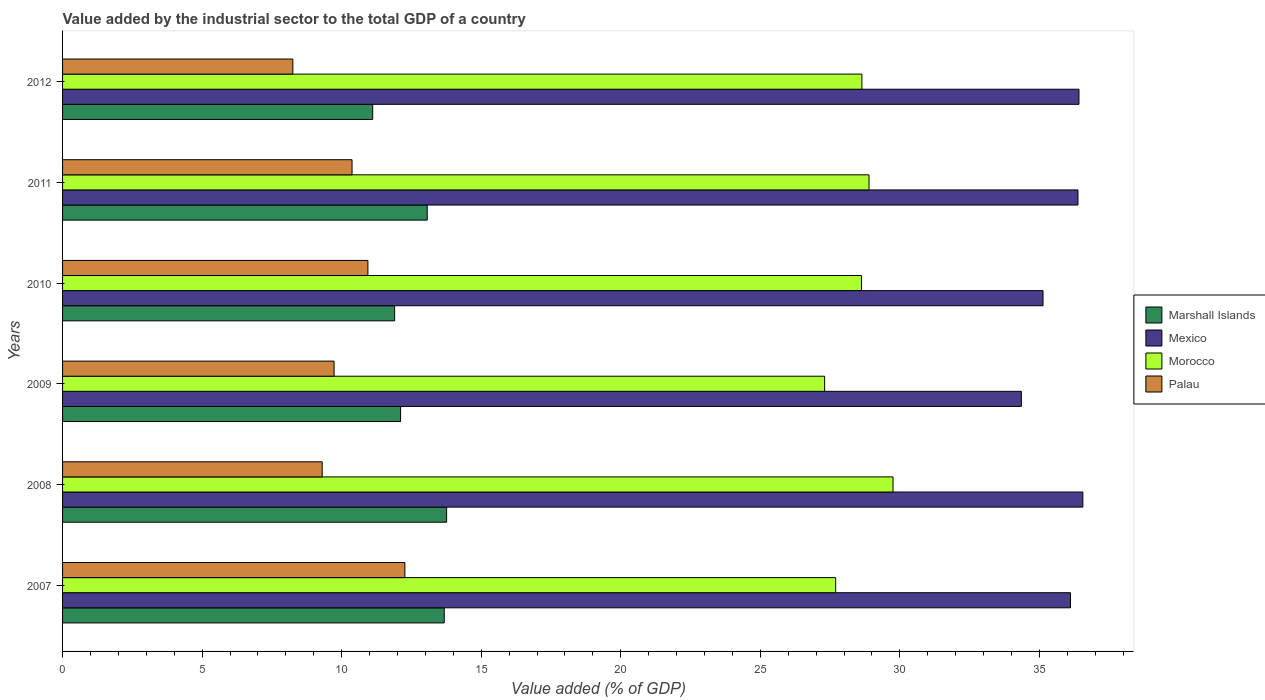Are the number of bars per tick equal to the number of legend labels?
Make the answer very short. Yes. Are the number of bars on each tick of the Y-axis equal?
Offer a terse response. Yes. How many bars are there on the 4th tick from the top?
Ensure brevity in your answer.  4. In how many cases, is the number of bars for a given year not equal to the number of legend labels?
Your response must be concise. 0. What is the value added by the industrial sector to the total GDP in Marshall Islands in 2007?
Your answer should be very brief. 13.68. Across all years, what is the maximum value added by the industrial sector to the total GDP in Marshall Islands?
Offer a terse response. 13.76. Across all years, what is the minimum value added by the industrial sector to the total GDP in Palau?
Keep it short and to the point. 8.25. What is the total value added by the industrial sector to the total GDP in Morocco in the graph?
Your answer should be very brief. 170.91. What is the difference between the value added by the industrial sector to the total GDP in Mexico in 2007 and that in 2008?
Make the answer very short. -0.44. What is the difference between the value added by the industrial sector to the total GDP in Marshall Islands in 2008 and the value added by the industrial sector to the total GDP in Palau in 2007?
Offer a terse response. 1.5. What is the average value added by the industrial sector to the total GDP in Palau per year?
Give a very brief answer. 10.14. In the year 2010, what is the difference between the value added by the industrial sector to the total GDP in Marshall Islands and value added by the industrial sector to the total GDP in Mexico?
Provide a short and direct response. -23.23. What is the ratio of the value added by the industrial sector to the total GDP in Palau in 2008 to that in 2012?
Give a very brief answer. 1.13. Is the difference between the value added by the industrial sector to the total GDP in Marshall Islands in 2009 and 2012 greater than the difference between the value added by the industrial sector to the total GDP in Mexico in 2009 and 2012?
Provide a succinct answer. Yes. What is the difference between the highest and the second highest value added by the industrial sector to the total GDP in Mexico?
Give a very brief answer. 0.14. What is the difference between the highest and the lowest value added by the industrial sector to the total GDP in Palau?
Keep it short and to the point. 4.01. Is it the case that in every year, the sum of the value added by the industrial sector to the total GDP in Mexico and value added by the industrial sector to the total GDP in Morocco is greater than the sum of value added by the industrial sector to the total GDP in Palau and value added by the industrial sector to the total GDP in Marshall Islands?
Your answer should be very brief. No. What does the 1st bar from the top in 2008 represents?
Your answer should be compact. Palau. What does the 3rd bar from the bottom in 2009 represents?
Make the answer very short. Morocco. Is it the case that in every year, the sum of the value added by the industrial sector to the total GDP in Mexico and value added by the industrial sector to the total GDP in Marshall Islands is greater than the value added by the industrial sector to the total GDP in Palau?
Provide a short and direct response. Yes. How many bars are there?
Your answer should be compact. 24. Are all the bars in the graph horizontal?
Your answer should be very brief. Yes. How many years are there in the graph?
Ensure brevity in your answer.  6. What is the difference between two consecutive major ticks on the X-axis?
Your answer should be compact. 5. Are the values on the major ticks of X-axis written in scientific E-notation?
Make the answer very short. No. Does the graph contain grids?
Offer a terse response. No. How many legend labels are there?
Make the answer very short. 4. How are the legend labels stacked?
Provide a succinct answer. Vertical. What is the title of the graph?
Your answer should be compact. Value added by the industrial sector to the total GDP of a country. What is the label or title of the X-axis?
Make the answer very short. Value added (% of GDP). What is the Value added (% of GDP) in Marshall Islands in 2007?
Your answer should be very brief. 13.68. What is the Value added (% of GDP) in Mexico in 2007?
Provide a succinct answer. 36.11. What is the Value added (% of GDP) in Morocco in 2007?
Your answer should be very brief. 27.7. What is the Value added (% of GDP) of Palau in 2007?
Offer a terse response. 12.26. What is the Value added (% of GDP) in Marshall Islands in 2008?
Ensure brevity in your answer.  13.76. What is the Value added (% of GDP) of Mexico in 2008?
Give a very brief answer. 36.56. What is the Value added (% of GDP) in Morocco in 2008?
Keep it short and to the point. 29.75. What is the Value added (% of GDP) in Palau in 2008?
Keep it short and to the point. 9.3. What is the Value added (% of GDP) in Marshall Islands in 2009?
Offer a very short reply. 12.11. What is the Value added (% of GDP) in Mexico in 2009?
Keep it short and to the point. 34.35. What is the Value added (% of GDP) in Morocco in 2009?
Offer a terse response. 27.3. What is the Value added (% of GDP) in Palau in 2009?
Offer a very short reply. 9.73. What is the Value added (% of GDP) in Marshall Islands in 2010?
Make the answer very short. 11.9. What is the Value added (% of GDP) in Mexico in 2010?
Offer a terse response. 35.13. What is the Value added (% of GDP) of Morocco in 2010?
Your answer should be very brief. 28.62. What is the Value added (% of GDP) in Palau in 2010?
Give a very brief answer. 10.94. What is the Value added (% of GDP) in Marshall Islands in 2011?
Make the answer very short. 13.07. What is the Value added (% of GDP) of Mexico in 2011?
Your response must be concise. 36.38. What is the Value added (% of GDP) of Morocco in 2011?
Give a very brief answer. 28.89. What is the Value added (% of GDP) of Palau in 2011?
Keep it short and to the point. 10.37. What is the Value added (% of GDP) in Marshall Islands in 2012?
Your response must be concise. 11.11. What is the Value added (% of GDP) of Mexico in 2012?
Offer a terse response. 36.42. What is the Value added (% of GDP) of Morocco in 2012?
Provide a succinct answer. 28.64. What is the Value added (% of GDP) in Palau in 2012?
Make the answer very short. 8.25. Across all years, what is the maximum Value added (% of GDP) of Marshall Islands?
Give a very brief answer. 13.76. Across all years, what is the maximum Value added (% of GDP) in Mexico?
Your answer should be compact. 36.56. Across all years, what is the maximum Value added (% of GDP) of Morocco?
Keep it short and to the point. 29.75. Across all years, what is the maximum Value added (% of GDP) in Palau?
Your answer should be very brief. 12.26. Across all years, what is the minimum Value added (% of GDP) of Marshall Islands?
Your answer should be compact. 11.11. Across all years, what is the minimum Value added (% of GDP) of Mexico?
Your answer should be compact. 34.35. Across all years, what is the minimum Value added (% of GDP) of Morocco?
Your answer should be compact. 27.3. Across all years, what is the minimum Value added (% of GDP) in Palau?
Your response must be concise. 8.25. What is the total Value added (% of GDP) in Marshall Islands in the graph?
Provide a succinct answer. 75.62. What is the total Value added (% of GDP) in Mexico in the graph?
Ensure brevity in your answer.  214.95. What is the total Value added (% of GDP) in Morocco in the graph?
Make the answer very short. 170.91. What is the total Value added (% of GDP) in Palau in the graph?
Make the answer very short. 60.86. What is the difference between the Value added (% of GDP) in Marshall Islands in 2007 and that in 2008?
Provide a short and direct response. -0.08. What is the difference between the Value added (% of GDP) in Mexico in 2007 and that in 2008?
Provide a succinct answer. -0.44. What is the difference between the Value added (% of GDP) in Morocco in 2007 and that in 2008?
Make the answer very short. -2.06. What is the difference between the Value added (% of GDP) in Palau in 2007 and that in 2008?
Offer a terse response. 2.96. What is the difference between the Value added (% of GDP) of Marshall Islands in 2007 and that in 2009?
Ensure brevity in your answer.  1.56. What is the difference between the Value added (% of GDP) in Mexico in 2007 and that in 2009?
Your answer should be very brief. 1.76. What is the difference between the Value added (% of GDP) in Morocco in 2007 and that in 2009?
Keep it short and to the point. 0.4. What is the difference between the Value added (% of GDP) of Palau in 2007 and that in 2009?
Offer a very short reply. 2.54. What is the difference between the Value added (% of GDP) in Marshall Islands in 2007 and that in 2010?
Provide a succinct answer. 1.78. What is the difference between the Value added (% of GDP) of Mexico in 2007 and that in 2010?
Provide a succinct answer. 0.98. What is the difference between the Value added (% of GDP) of Morocco in 2007 and that in 2010?
Give a very brief answer. -0.92. What is the difference between the Value added (% of GDP) in Palau in 2007 and that in 2010?
Your answer should be compact. 1.32. What is the difference between the Value added (% of GDP) in Marshall Islands in 2007 and that in 2011?
Provide a succinct answer. 0.61. What is the difference between the Value added (% of GDP) in Mexico in 2007 and that in 2011?
Your answer should be compact. -0.27. What is the difference between the Value added (% of GDP) in Morocco in 2007 and that in 2011?
Provide a succinct answer. -1.19. What is the difference between the Value added (% of GDP) in Palau in 2007 and that in 2011?
Your answer should be very brief. 1.89. What is the difference between the Value added (% of GDP) of Marshall Islands in 2007 and that in 2012?
Provide a succinct answer. 2.56. What is the difference between the Value added (% of GDP) of Mexico in 2007 and that in 2012?
Keep it short and to the point. -0.3. What is the difference between the Value added (% of GDP) in Morocco in 2007 and that in 2012?
Offer a terse response. -0.94. What is the difference between the Value added (% of GDP) in Palau in 2007 and that in 2012?
Offer a very short reply. 4.01. What is the difference between the Value added (% of GDP) of Marshall Islands in 2008 and that in 2009?
Your answer should be compact. 1.65. What is the difference between the Value added (% of GDP) of Mexico in 2008 and that in 2009?
Offer a very short reply. 2.2. What is the difference between the Value added (% of GDP) in Morocco in 2008 and that in 2009?
Offer a very short reply. 2.45. What is the difference between the Value added (% of GDP) of Palau in 2008 and that in 2009?
Give a very brief answer. -0.43. What is the difference between the Value added (% of GDP) of Marshall Islands in 2008 and that in 2010?
Make the answer very short. 1.86. What is the difference between the Value added (% of GDP) in Mexico in 2008 and that in 2010?
Your answer should be compact. 1.43. What is the difference between the Value added (% of GDP) in Morocco in 2008 and that in 2010?
Give a very brief answer. 1.13. What is the difference between the Value added (% of GDP) in Palau in 2008 and that in 2010?
Make the answer very short. -1.64. What is the difference between the Value added (% of GDP) in Marshall Islands in 2008 and that in 2011?
Provide a short and direct response. 0.69. What is the difference between the Value added (% of GDP) of Mexico in 2008 and that in 2011?
Give a very brief answer. 0.17. What is the difference between the Value added (% of GDP) of Morocco in 2008 and that in 2011?
Keep it short and to the point. 0.86. What is the difference between the Value added (% of GDP) of Palau in 2008 and that in 2011?
Ensure brevity in your answer.  -1.07. What is the difference between the Value added (% of GDP) of Marshall Islands in 2008 and that in 2012?
Your answer should be very brief. 2.65. What is the difference between the Value added (% of GDP) in Mexico in 2008 and that in 2012?
Give a very brief answer. 0.14. What is the difference between the Value added (% of GDP) in Morocco in 2008 and that in 2012?
Give a very brief answer. 1.12. What is the difference between the Value added (% of GDP) of Palau in 2008 and that in 2012?
Give a very brief answer. 1.05. What is the difference between the Value added (% of GDP) of Marshall Islands in 2009 and that in 2010?
Keep it short and to the point. 0.21. What is the difference between the Value added (% of GDP) of Mexico in 2009 and that in 2010?
Keep it short and to the point. -0.78. What is the difference between the Value added (% of GDP) in Morocco in 2009 and that in 2010?
Your answer should be compact. -1.32. What is the difference between the Value added (% of GDP) of Palau in 2009 and that in 2010?
Give a very brief answer. -1.21. What is the difference between the Value added (% of GDP) in Marshall Islands in 2009 and that in 2011?
Provide a short and direct response. -0.96. What is the difference between the Value added (% of GDP) in Mexico in 2009 and that in 2011?
Offer a terse response. -2.03. What is the difference between the Value added (% of GDP) in Morocco in 2009 and that in 2011?
Offer a terse response. -1.59. What is the difference between the Value added (% of GDP) in Palau in 2009 and that in 2011?
Offer a very short reply. -0.64. What is the difference between the Value added (% of GDP) in Marshall Islands in 2009 and that in 2012?
Make the answer very short. 1. What is the difference between the Value added (% of GDP) in Mexico in 2009 and that in 2012?
Your response must be concise. -2.06. What is the difference between the Value added (% of GDP) in Morocco in 2009 and that in 2012?
Provide a short and direct response. -1.34. What is the difference between the Value added (% of GDP) in Palau in 2009 and that in 2012?
Offer a terse response. 1.48. What is the difference between the Value added (% of GDP) of Marshall Islands in 2010 and that in 2011?
Make the answer very short. -1.17. What is the difference between the Value added (% of GDP) in Mexico in 2010 and that in 2011?
Provide a short and direct response. -1.25. What is the difference between the Value added (% of GDP) of Morocco in 2010 and that in 2011?
Your response must be concise. -0.27. What is the difference between the Value added (% of GDP) in Palau in 2010 and that in 2011?
Keep it short and to the point. 0.57. What is the difference between the Value added (% of GDP) in Marshall Islands in 2010 and that in 2012?
Ensure brevity in your answer.  0.79. What is the difference between the Value added (% of GDP) of Mexico in 2010 and that in 2012?
Make the answer very short. -1.29. What is the difference between the Value added (% of GDP) in Morocco in 2010 and that in 2012?
Your answer should be compact. -0.02. What is the difference between the Value added (% of GDP) in Palau in 2010 and that in 2012?
Ensure brevity in your answer.  2.69. What is the difference between the Value added (% of GDP) in Marshall Islands in 2011 and that in 2012?
Provide a short and direct response. 1.95. What is the difference between the Value added (% of GDP) of Mexico in 2011 and that in 2012?
Ensure brevity in your answer.  -0.04. What is the difference between the Value added (% of GDP) of Morocco in 2011 and that in 2012?
Keep it short and to the point. 0.26. What is the difference between the Value added (% of GDP) of Palau in 2011 and that in 2012?
Your answer should be very brief. 2.12. What is the difference between the Value added (% of GDP) of Marshall Islands in 2007 and the Value added (% of GDP) of Mexico in 2008?
Your answer should be very brief. -22.88. What is the difference between the Value added (% of GDP) in Marshall Islands in 2007 and the Value added (% of GDP) in Morocco in 2008?
Give a very brief answer. -16.08. What is the difference between the Value added (% of GDP) in Marshall Islands in 2007 and the Value added (% of GDP) in Palau in 2008?
Offer a very short reply. 4.37. What is the difference between the Value added (% of GDP) of Mexico in 2007 and the Value added (% of GDP) of Morocco in 2008?
Provide a succinct answer. 6.36. What is the difference between the Value added (% of GDP) in Mexico in 2007 and the Value added (% of GDP) in Palau in 2008?
Make the answer very short. 26.81. What is the difference between the Value added (% of GDP) in Morocco in 2007 and the Value added (% of GDP) in Palau in 2008?
Offer a terse response. 18.4. What is the difference between the Value added (% of GDP) of Marshall Islands in 2007 and the Value added (% of GDP) of Mexico in 2009?
Provide a short and direct response. -20.68. What is the difference between the Value added (% of GDP) of Marshall Islands in 2007 and the Value added (% of GDP) of Morocco in 2009?
Your answer should be compact. -13.63. What is the difference between the Value added (% of GDP) in Marshall Islands in 2007 and the Value added (% of GDP) in Palau in 2009?
Keep it short and to the point. 3.95. What is the difference between the Value added (% of GDP) of Mexico in 2007 and the Value added (% of GDP) of Morocco in 2009?
Offer a very short reply. 8.81. What is the difference between the Value added (% of GDP) in Mexico in 2007 and the Value added (% of GDP) in Palau in 2009?
Your response must be concise. 26.39. What is the difference between the Value added (% of GDP) of Morocco in 2007 and the Value added (% of GDP) of Palau in 2009?
Make the answer very short. 17.97. What is the difference between the Value added (% of GDP) in Marshall Islands in 2007 and the Value added (% of GDP) in Mexico in 2010?
Your response must be concise. -21.45. What is the difference between the Value added (% of GDP) in Marshall Islands in 2007 and the Value added (% of GDP) in Morocco in 2010?
Your answer should be compact. -14.95. What is the difference between the Value added (% of GDP) in Marshall Islands in 2007 and the Value added (% of GDP) in Palau in 2010?
Offer a very short reply. 2.73. What is the difference between the Value added (% of GDP) in Mexico in 2007 and the Value added (% of GDP) in Morocco in 2010?
Offer a very short reply. 7.49. What is the difference between the Value added (% of GDP) in Mexico in 2007 and the Value added (% of GDP) in Palau in 2010?
Provide a short and direct response. 25.17. What is the difference between the Value added (% of GDP) in Morocco in 2007 and the Value added (% of GDP) in Palau in 2010?
Your answer should be very brief. 16.76. What is the difference between the Value added (% of GDP) in Marshall Islands in 2007 and the Value added (% of GDP) in Mexico in 2011?
Make the answer very short. -22.71. What is the difference between the Value added (% of GDP) in Marshall Islands in 2007 and the Value added (% of GDP) in Morocco in 2011?
Provide a short and direct response. -15.22. What is the difference between the Value added (% of GDP) of Marshall Islands in 2007 and the Value added (% of GDP) of Palau in 2011?
Keep it short and to the point. 3.3. What is the difference between the Value added (% of GDP) in Mexico in 2007 and the Value added (% of GDP) in Morocco in 2011?
Provide a short and direct response. 7.22. What is the difference between the Value added (% of GDP) of Mexico in 2007 and the Value added (% of GDP) of Palau in 2011?
Keep it short and to the point. 25.74. What is the difference between the Value added (% of GDP) of Morocco in 2007 and the Value added (% of GDP) of Palau in 2011?
Your answer should be very brief. 17.33. What is the difference between the Value added (% of GDP) in Marshall Islands in 2007 and the Value added (% of GDP) in Mexico in 2012?
Give a very brief answer. -22.74. What is the difference between the Value added (% of GDP) in Marshall Islands in 2007 and the Value added (% of GDP) in Morocco in 2012?
Make the answer very short. -14.96. What is the difference between the Value added (% of GDP) in Marshall Islands in 2007 and the Value added (% of GDP) in Palau in 2012?
Your response must be concise. 5.42. What is the difference between the Value added (% of GDP) in Mexico in 2007 and the Value added (% of GDP) in Morocco in 2012?
Provide a short and direct response. 7.47. What is the difference between the Value added (% of GDP) of Mexico in 2007 and the Value added (% of GDP) of Palau in 2012?
Provide a succinct answer. 27.86. What is the difference between the Value added (% of GDP) of Morocco in 2007 and the Value added (% of GDP) of Palau in 2012?
Ensure brevity in your answer.  19.45. What is the difference between the Value added (% of GDP) of Marshall Islands in 2008 and the Value added (% of GDP) of Mexico in 2009?
Offer a very short reply. -20.59. What is the difference between the Value added (% of GDP) in Marshall Islands in 2008 and the Value added (% of GDP) in Morocco in 2009?
Ensure brevity in your answer.  -13.54. What is the difference between the Value added (% of GDP) of Marshall Islands in 2008 and the Value added (% of GDP) of Palau in 2009?
Offer a terse response. 4.03. What is the difference between the Value added (% of GDP) of Mexico in 2008 and the Value added (% of GDP) of Morocco in 2009?
Provide a succinct answer. 9.25. What is the difference between the Value added (% of GDP) in Mexico in 2008 and the Value added (% of GDP) in Palau in 2009?
Provide a short and direct response. 26.83. What is the difference between the Value added (% of GDP) in Morocco in 2008 and the Value added (% of GDP) in Palau in 2009?
Keep it short and to the point. 20.03. What is the difference between the Value added (% of GDP) in Marshall Islands in 2008 and the Value added (% of GDP) in Mexico in 2010?
Keep it short and to the point. -21.37. What is the difference between the Value added (% of GDP) in Marshall Islands in 2008 and the Value added (% of GDP) in Morocco in 2010?
Your response must be concise. -14.86. What is the difference between the Value added (% of GDP) in Marshall Islands in 2008 and the Value added (% of GDP) in Palau in 2010?
Your answer should be compact. 2.82. What is the difference between the Value added (% of GDP) in Mexico in 2008 and the Value added (% of GDP) in Morocco in 2010?
Provide a succinct answer. 7.93. What is the difference between the Value added (% of GDP) of Mexico in 2008 and the Value added (% of GDP) of Palau in 2010?
Ensure brevity in your answer.  25.62. What is the difference between the Value added (% of GDP) of Morocco in 2008 and the Value added (% of GDP) of Palau in 2010?
Your response must be concise. 18.81. What is the difference between the Value added (% of GDP) in Marshall Islands in 2008 and the Value added (% of GDP) in Mexico in 2011?
Make the answer very short. -22.62. What is the difference between the Value added (% of GDP) in Marshall Islands in 2008 and the Value added (% of GDP) in Morocco in 2011?
Provide a short and direct response. -15.13. What is the difference between the Value added (% of GDP) in Marshall Islands in 2008 and the Value added (% of GDP) in Palau in 2011?
Offer a terse response. 3.39. What is the difference between the Value added (% of GDP) in Mexico in 2008 and the Value added (% of GDP) in Morocco in 2011?
Provide a succinct answer. 7.66. What is the difference between the Value added (% of GDP) in Mexico in 2008 and the Value added (% of GDP) in Palau in 2011?
Your answer should be very brief. 26.18. What is the difference between the Value added (% of GDP) in Morocco in 2008 and the Value added (% of GDP) in Palau in 2011?
Provide a short and direct response. 19.38. What is the difference between the Value added (% of GDP) of Marshall Islands in 2008 and the Value added (% of GDP) of Mexico in 2012?
Provide a succinct answer. -22.66. What is the difference between the Value added (% of GDP) in Marshall Islands in 2008 and the Value added (% of GDP) in Morocco in 2012?
Provide a succinct answer. -14.88. What is the difference between the Value added (% of GDP) in Marshall Islands in 2008 and the Value added (% of GDP) in Palau in 2012?
Keep it short and to the point. 5.51. What is the difference between the Value added (% of GDP) of Mexico in 2008 and the Value added (% of GDP) of Morocco in 2012?
Make the answer very short. 7.92. What is the difference between the Value added (% of GDP) of Mexico in 2008 and the Value added (% of GDP) of Palau in 2012?
Your answer should be compact. 28.31. What is the difference between the Value added (% of GDP) of Morocco in 2008 and the Value added (% of GDP) of Palau in 2012?
Keep it short and to the point. 21.5. What is the difference between the Value added (% of GDP) of Marshall Islands in 2009 and the Value added (% of GDP) of Mexico in 2010?
Provide a short and direct response. -23.02. What is the difference between the Value added (% of GDP) in Marshall Islands in 2009 and the Value added (% of GDP) in Morocco in 2010?
Offer a terse response. -16.51. What is the difference between the Value added (% of GDP) in Marshall Islands in 2009 and the Value added (% of GDP) in Palau in 2010?
Give a very brief answer. 1.17. What is the difference between the Value added (% of GDP) in Mexico in 2009 and the Value added (% of GDP) in Morocco in 2010?
Provide a succinct answer. 5.73. What is the difference between the Value added (% of GDP) of Mexico in 2009 and the Value added (% of GDP) of Palau in 2010?
Offer a terse response. 23.41. What is the difference between the Value added (% of GDP) in Morocco in 2009 and the Value added (% of GDP) in Palau in 2010?
Your answer should be compact. 16.36. What is the difference between the Value added (% of GDP) in Marshall Islands in 2009 and the Value added (% of GDP) in Mexico in 2011?
Your response must be concise. -24.27. What is the difference between the Value added (% of GDP) of Marshall Islands in 2009 and the Value added (% of GDP) of Morocco in 2011?
Provide a short and direct response. -16.78. What is the difference between the Value added (% of GDP) of Marshall Islands in 2009 and the Value added (% of GDP) of Palau in 2011?
Make the answer very short. 1.74. What is the difference between the Value added (% of GDP) of Mexico in 2009 and the Value added (% of GDP) of Morocco in 2011?
Offer a terse response. 5.46. What is the difference between the Value added (% of GDP) in Mexico in 2009 and the Value added (% of GDP) in Palau in 2011?
Offer a very short reply. 23.98. What is the difference between the Value added (% of GDP) of Morocco in 2009 and the Value added (% of GDP) of Palau in 2011?
Offer a very short reply. 16.93. What is the difference between the Value added (% of GDP) in Marshall Islands in 2009 and the Value added (% of GDP) in Mexico in 2012?
Your answer should be compact. -24.31. What is the difference between the Value added (% of GDP) in Marshall Islands in 2009 and the Value added (% of GDP) in Morocco in 2012?
Your answer should be compact. -16.53. What is the difference between the Value added (% of GDP) of Marshall Islands in 2009 and the Value added (% of GDP) of Palau in 2012?
Ensure brevity in your answer.  3.86. What is the difference between the Value added (% of GDP) of Mexico in 2009 and the Value added (% of GDP) of Morocco in 2012?
Keep it short and to the point. 5.71. What is the difference between the Value added (% of GDP) of Mexico in 2009 and the Value added (% of GDP) of Palau in 2012?
Make the answer very short. 26.1. What is the difference between the Value added (% of GDP) of Morocco in 2009 and the Value added (% of GDP) of Palau in 2012?
Offer a terse response. 19.05. What is the difference between the Value added (% of GDP) of Marshall Islands in 2010 and the Value added (% of GDP) of Mexico in 2011?
Ensure brevity in your answer.  -24.48. What is the difference between the Value added (% of GDP) in Marshall Islands in 2010 and the Value added (% of GDP) in Morocco in 2011?
Your answer should be compact. -17. What is the difference between the Value added (% of GDP) of Marshall Islands in 2010 and the Value added (% of GDP) of Palau in 2011?
Ensure brevity in your answer.  1.53. What is the difference between the Value added (% of GDP) in Mexico in 2010 and the Value added (% of GDP) in Morocco in 2011?
Offer a terse response. 6.23. What is the difference between the Value added (% of GDP) of Mexico in 2010 and the Value added (% of GDP) of Palau in 2011?
Offer a terse response. 24.76. What is the difference between the Value added (% of GDP) in Morocco in 2010 and the Value added (% of GDP) in Palau in 2011?
Ensure brevity in your answer.  18.25. What is the difference between the Value added (% of GDP) of Marshall Islands in 2010 and the Value added (% of GDP) of Mexico in 2012?
Offer a terse response. -24.52. What is the difference between the Value added (% of GDP) in Marshall Islands in 2010 and the Value added (% of GDP) in Morocco in 2012?
Keep it short and to the point. -16.74. What is the difference between the Value added (% of GDP) of Marshall Islands in 2010 and the Value added (% of GDP) of Palau in 2012?
Provide a succinct answer. 3.65. What is the difference between the Value added (% of GDP) of Mexico in 2010 and the Value added (% of GDP) of Morocco in 2012?
Keep it short and to the point. 6.49. What is the difference between the Value added (% of GDP) in Mexico in 2010 and the Value added (% of GDP) in Palau in 2012?
Make the answer very short. 26.88. What is the difference between the Value added (% of GDP) of Morocco in 2010 and the Value added (% of GDP) of Palau in 2012?
Keep it short and to the point. 20.37. What is the difference between the Value added (% of GDP) of Marshall Islands in 2011 and the Value added (% of GDP) of Mexico in 2012?
Provide a succinct answer. -23.35. What is the difference between the Value added (% of GDP) of Marshall Islands in 2011 and the Value added (% of GDP) of Morocco in 2012?
Your answer should be very brief. -15.57. What is the difference between the Value added (% of GDP) of Marshall Islands in 2011 and the Value added (% of GDP) of Palau in 2012?
Your answer should be compact. 4.82. What is the difference between the Value added (% of GDP) in Mexico in 2011 and the Value added (% of GDP) in Morocco in 2012?
Keep it short and to the point. 7.74. What is the difference between the Value added (% of GDP) of Mexico in 2011 and the Value added (% of GDP) of Palau in 2012?
Give a very brief answer. 28.13. What is the difference between the Value added (% of GDP) in Morocco in 2011 and the Value added (% of GDP) in Palau in 2012?
Keep it short and to the point. 20.64. What is the average Value added (% of GDP) in Marshall Islands per year?
Offer a terse response. 12.6. What is the average Value added (% of GDP) in Mexico per year?
Offer a very short reply. 35.82. What is the average Value added (% of GDP) of Morocco per year?
Provide a succinct answer. 28.49. What is the average Value added (% of GDP) in Palau per year?
Ensure brevity in your answer.  10.14. In the year 2007, what is the difference between the Value added (% of GDP) in Marshall Islands and Value added (% of GDP) in Mexico?
Provide a succinct answer. -22.44. In the year 2007, what is the difference between the Value added (% of GDP) of Marshall Islands and Value added (% of GDP) of Morocco?
Provide a short and direct response. -14.02. In the year 2007, what is the difference between the Value added (% of GDP) of Marshall Islands and Value added (% of GDP) of Palau?
Your response must be concise. 1.41. In the year 2007, what is the difference between the Value added (% of GDP) of Mexico and Value added (% of GDP) of Morocco?
Ensure brevity in your answer.  8.41. In the year 2007, what is the difference between the Value added (% of GDP) in Mexico and Value added (% of GDP) in Palau?
Keep it short and to the point. 23.85. In the year 2007, what is the difference between the Value added (% of GDP) in Morocco and Value added (% of GDP) in Palau?
Make the answer very short. 15.44. In the year 2008, what is the difference between the Value added (% of GDP) of Marshall Islands and Value added (% of GDP) of Mexico?
Provide a short and direct response. -22.8. In the year 2008, what is the difference between the Value added (% of GDP) in Marshall Islands and Value added (% of GDP) in Morocco?
Offer a very short reply. -15.99. In the year 2008, what is the difference between the Value added (% of GDP) of Marshall Islands and Value added (% of GDP) of Palau?
Offer a very short reply. 4.46. In the year 2008, what is the difference between the Value added (% of GDP) of Mexico and Value added (% of GDP) of Morocco?
Your answer should be compact. 6.8. In the year 2008, what is the difference between the Value added (% of GDP) of Mexico and Value added (% of GDP) of Palau?
Give a very brief answer. 27.25. In the year 2008, what is the difference between the Value added (% of GDP) in Morocco and Value added (% of GDP) in Palau?
Your answer should be very brief. 20.45. In the year 2009, what is the difference between the Value added (% of GDP) of Marshall Islands and Value added (% of GDP) of Mexico?
Offer a terse response. -22.24. In the year 2009, what is the difference between the Value added (% of GDP) of Marshall Islands and Value added (% of GDP) of Morocco?
Ensure brevity in your answer.  -15.19. In the year 2009, what is the difference between the Value added (% of GDP) of Marshall Islands and Value added (% of GDP) of Palau?
Provide a short and direct response. 2.38. In the year 2009, what is the difference between the Value added (% of GDP) of Mexico and Value added (% of GDP) of Morocco?
Offer a terse response. 7.05. In the year 2009, what is the difference between the Value added (% of GDP) in Mexico and Value added (% of GDP) in Palau?
Make the answer very short. 24.63. In the year 2009, what is the difference between the Value added (% of GDP) of Morocco and Value added (% of GDP) of Palau?
Your answer should be very brief. 17.58. In the year 2010, what is the difference between the Value added (% of GDP) in Marshall Islands and Value added (% of GDP) in Mexico?
Keep it short and to the point. -23.23. In the year 2010, what is the difference between the Value added (% of GDP) in Marshall Islands and Value added (% of GDP) in Morocco?
Keep it short and to the point. -16.73. In the year 2010, what is the difference between the Value added (% of GDP) of Marshall Islands and Value added (% of GDP) of Palau?
Your answer should be very brief. 0.96. In the year 2010, what is the difference between the Value added (% of GDP) in Mexico and Value added (% of GDP) in Morocco?
Give a very brief answer. 6.5. In the year 2010, what is the difference between the Value added (% of GDP) of Mexico and Value added (% of GDP) of Palau?
Give a very brief answer. 24.19. In the year 2010, what is the difference between the Value added (% of GDP) of Morocco and Value added (% of GDP) of Palau?
Provide a short and direct response. 17.68. In the year 2011, what is the difference between the Value added (% of GDP) of Marshall Islands and Value added (% of GDP) of Mexico?
Provide a succinct answer. -23.32. In the year 2011, what is the difference between the Value added (% of GDP) in Marshall Islands and Value added (% of GDP) in Morocco?
Make the answer very short. -15.83. In the year 2011, what is the difference between the Value added (% of GDP) of Marshall Islands and Value added (% of GDP) of Palau?
Give a very brief answer. 2.69. In the year 2011, what is the difference between the Value added (% of GDP) in Mexico and Value added (% of GDP) in Morocco?
Offer a very short reply. 7.49. In the year 2011, what is the difference between the Value added (% of GDP) in Mexico and Value added (% of GDP) in Palau?
Your response must be concise. 26.01. In the year 2011, what is the difference between the Value added (% of GDP) of Morocco and Value added (% of GDP) of Palau?
Provide a short and direct response. 18.52. In the year 2012, what is the difference between the Value added (% of GDP) in Marshall Islands and Value added (% of GDP) in Mexico?
Ensure brevity in your answer.  -25.3. In the year 2012, what is the difference between the Value added (% of GDP) in Marshall Islands and Value added (% of GDP) in Morocco?
Keep it short and to the point. -17.53. In the year 2012, what is the difference between the Value added (% of GDP) in Marshall Islands and Value added (% of GDP) in Palau?
Your response must be concise. 2.86. In the year 2012, what is the difference between the Value added (% of GDP) of Mexico and Value added (% of GDP) of Morocco?
Your answer should be compact. 7.78. In the year 2012, what is the difference between the Value added (% of GDP) of Mexico and Value added (% of GDP) of Palau?
Ensure brevity in your answer.  28.17. In the year 2012, what is the difference between the Value added (% of GDP) of Morocco and Value added (% of GDP) of Palau?
Offer a very short reply. 20.39. What is the ratio of the Value added (% of GDP) of Marshall Islands in 2007 to that in 2008?
Provide a short and direct response. 0.99. What is the ratio of the Value added (% of GDP) in Mexico in 2007 to that in 2008?
Keep it short and to the point. 0.99. What is the ratio of the Value added (% of GDP) of Morocco in 2007 to that in 2008?
Offer a very short reply. 0.93. What is the ratio of the Value added (% of GDP) of Palau in 2007 to that in 2008?
Keep it short and to the point. 1.32. What is the ratio of the Value added (% of GDP) in Marshall Islands in 2007 to that in 2009?
Offer a very short reply. 1.13. What is the ratio of the Value added (% of GDP) in Mexico in 2007 to that in 2009?
Your response must be concise. 1.05. What is the ratio of the Value added (% of GDP) of Morocco in 2007 to that in 2009?
Keep it short and to the point. 1.01. What is the ratio of the Value added (% of GDP) in Palau in 2007 to that in 2009?
Provide a short and direct response. 1.26. What is the ratio of the Value added (% of GDP) in Marshall Islands in 2007 to that in 2010?
Make the answer very short. 1.15. What is the ratio of the Value added (% of GDP) of Mexico in 2007 to that in 2010?
Offer a very short reply. 1.03. What is the ratio of the Value added (% of GDP) of Palau in 2007 to that in 2010?
Provide a short and direct response. 1.12. What is the ratio of the Value added (% of GDP) of Marshall Islands in 2007 to that in 2011?
Provide a succinct answer. 1.05. What is the ratio of the Value added (% of GDP) of Mexico in 2007 to that in 2011?
Ensure brevity in your answer.  0.99. What is the ratio of the Value added (% of GDP) in Morocco in 2007 to that in 2011?
Give a very brief answer. 0.96. What is the ratio of the Value added (% of GDP) in Palau in 2007 to that in 2011?
Your response must be concise. 1.18. What is the ratio of the Value added (% of GDP) in Marshall Islands in 2007 to that in 2012?
Your answer should be very brief. 1.23. What is the ratio of the Value added (% of GDP) of Morocco in 2007 to that in 2012?
Offer a terse response. 0.97. What is the ratio of the Value added (% of GDP) of Palau in 2007 to that in 2012?
Provide a succinct answer. 1.49. What is the ratio of the Value added (% of GDP) of Marshall Islands in 2008 to that in 2009?
Keep it short and to the point. 1.14. What is the ratio of the Value added (% of GDP) of Mexico in 2008 to that in 2009?
Provide a short and direct response. 1.06. What is the ratio of the Value added (% of GDP) of Morocco in 2008 to that in 2009?
Offer a very short reply. 1.09. What is the ratio of the Value added (% of GDP) in Palau in 2008 to that in 2009?
Give a very brief answer. 0.96. What is the ratio of the Value added (% of GDP) of Marshall Islands in 2008 to that in 2010?
Give a very brief answer. 1.16. What is the ratio of the Value added (% of GDP) of Mexico in 2008 to that in 2010?
Keep it short and to the point. 1.04. What is the ratio of the Value added (% of GDP) of Morocco in 2008 to that in 2010?
Offer a very short reply. 1.04. What is the ratio of the Value added (% of GDP) in Palau in 2008 to that in 2010?
Make the answer very short. 0.85. What is the ratio of the Value added (% of GDP) in Marshall Islands in 2008 to that in 2011?
Your response must be concise. 1.05. What is the ratio of the Value added (% of GDP) of Morocco in 2008 to that in 2011?
Make the answer very short. 1.03. What is the ratio of the Value added (% of GDP) in Palau in 2008 to that in 2011?
Your response must be concise. 0.9. What is the ratio of the Value added (% of GDP) of Marshall Islands in 2008 to that in 2012?
Your answer should be very brief. 1.24. What is the ratio of the Value added (% of GDP) of Morocco in 2008 to that in 2012?
Your answer should be very brief. 1.04. What is the ratio of the Value added (% of GDP) of Palau in 2008 to that in 2012?
Your answer should be compact. 1.13. What is the ratio of the Value added (% of GDP) of Marshall Islands in 2009 to that in 2010?
Give a very brief answer. 1.02. What is the ratio of the Value added (% of GDP) in Mexico in 2009 to that in 2010?
Your response must be concise. 0.98. What is the ratio of the Value added (% of GDP) of Morocco in 2009 to that in 2010?
Make the answer very short. 0.95. What is the ratio of the Value added (% of GDP) in Palau in 2009 to that in 2010?
Ensure brevity in your answer.  0.89. What is the ratio of the Value added (% of GDP) of Marshall Islands in 2009 to that in 2011?
Provide a short and direct response. 0.93. What is the ratio of the Value added (% of GDP) in Mexico in 2009 to that in 2011?
Offer a very short reply. 0.94. What is the ratio of the Value added (% of GDP) of Morocco in 2009 to that in 2011?
Your response must be concise. 0.94. What is the ratio of the Value added (% of GDP) of Palau in 2009 to that in 2011?
Give a very brief answer. 0.94. What is the ratio of the Value added (% of GDP) of Marshall Islands in 2009 to that in 2012?
Offer a terse response. 1.09. What is the ratio of the Value added (% of GDP) in Mexico in 2009 to that in 2012?
Provide a succinct answer. 0.94. What is the ratio of the Value added (% of GDP) of Morocco in 2009 to that in 2012?
Offer a terse response. 0.95. What is the ratio of the Value added (% of GDP) in Palau in 2009 to that in 2012?
Your answer should be very brief. 1.18. What is the ratio of the Value added (% of GDP) of Marshall Islands in 2010 to that in 2011?
Give a very brief answer. 0.91. What is the ratio of the Value added (% of GDP) in Mexico in 2010 to that in 2011?
Offer a terse response. 0.97. What is the ratio of the Value added (% of GDP) in Morocco in 2010 to that in 2011?
Ensure brevity in your answer.  0.99. What is the ratio of the Value added (% of GDP) of Palau in 2010 to that in 2011?
Provide a short and direct response. 1.05. What is the ratio of the Value added (% of GDP) of Marshall Islands in 2010 to that in 2012?
Ensure brevity in your answer.  1.07. What is the ratio of the Value added (% of GDP) of Mexico in 2010 to that in 2012?
Your answer should be very brief. 0.96. What is the ratio of the Value added (% of GDP) in Palau in 2010 to that in 2012?
Your answer should be compact. 1.33. What is the ratio of the Value added (% of GDP) in Marshall Islands in 2011 to that in 2012?
Ensure brevity in your answer.  1.18. What is the ratio of the Value added (% of GDP) in Mexico in 2011 to that in 2012?
Provide a short and direct response. 1. What is the ratio of the Value added (% of GDP) in Morocco in 2011 to that in 2012?
Your response must be concise. 1.01. What is the ratio of the Value added (% of GDP) of Palau in 2011 to that in 2012?
Ensure brevity in your answer.  1.26. What is the difference between the highest and the second highest Value added (% of GDP) of Marshall Islands?
Provide a short and direct response. 0.08. What is the difference between the highest and the second highest Value added (% of GDP) of Mexico?
Your answer should be very brief. 0.14. What is the difference between the highest and the second highest Value added (% of GDP) in Morocco?
Your answer should be compact. 0.86. What is the difference between the highest and the second highest Value added (% of GDP) of Palau?
Give a very brief answer. 1.32. What is the difference between the highest and the lowest Value added (% of GDP) of Marshall Islands?
Offer a very short reply. 2.65. What is the difference between the highest and the lowest Value added (% of GDP) of Mexico?
Provide a succinct answer. 2.2. What is the difference between the highest and the lowest Value added (% of GDP) in Morocco?
Your answer should be very brief. 2.45. What is the difference between the highest and the lowest Value added (% of GDP) in Palau?
Provide a succinct answer. 4.01. 